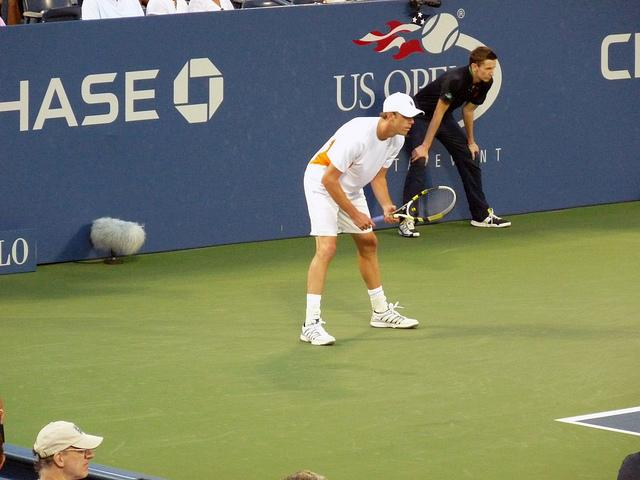What is the purpose of the white furry object? Please explain your reasoning. amplify sound. The object helps carry sound further. 